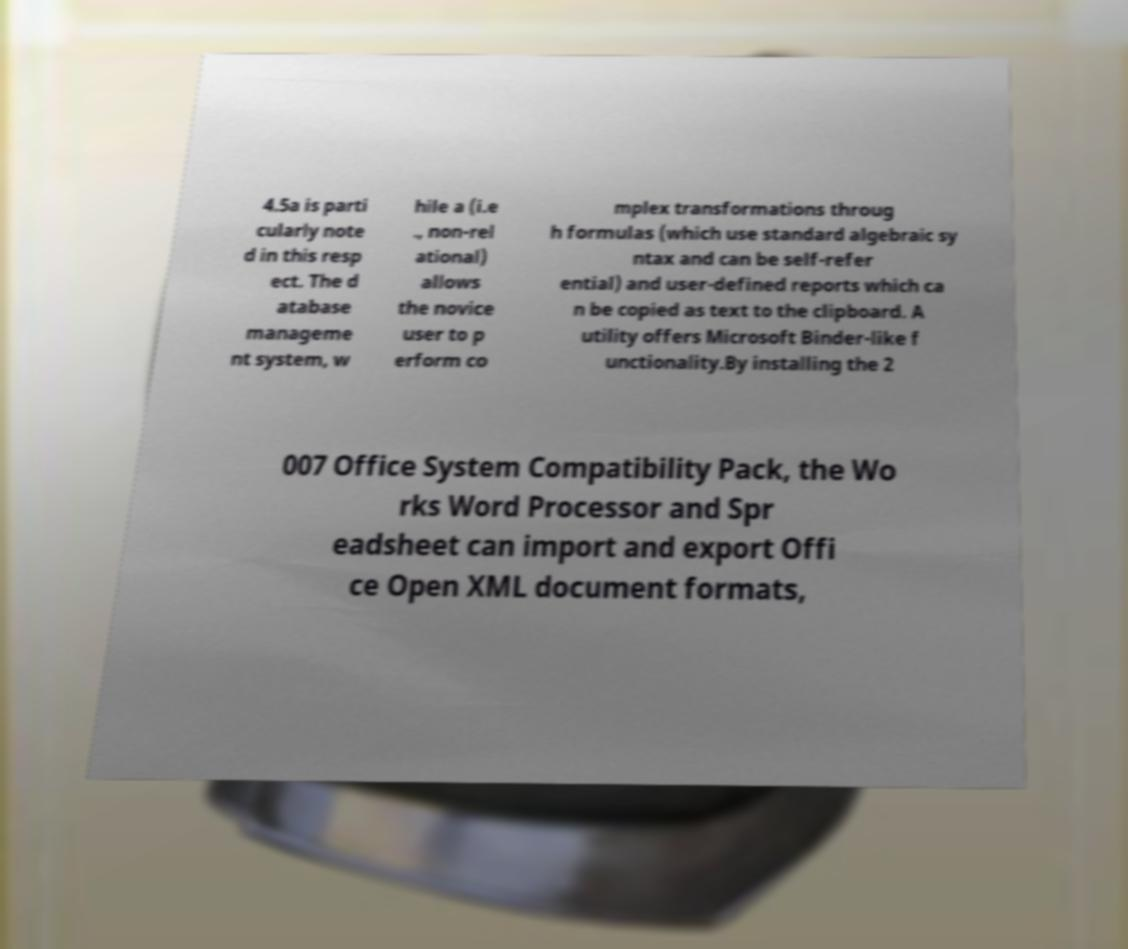There's text embedded in this image that I need extracted. Can you transcribe it verbatim? 4.5a is parti cularly note d in this resp ect. The d atabase manageme nt system, w hile a (i.e ., non-rel ational) allows the novice user to p erform co mplex transformations throug h formulas (which use standard algebraic sy ntax and can be self-refer ential) and user-defined reports which ca n be copied as text to the clipboard. A utility offers Microsoft Binder-like f unctionality.By installing the 2 007 Office System Compatibility Pack, the Wo rks Word Processor and Spr eadsheet can import and export Offi ce Open XML document formats, 